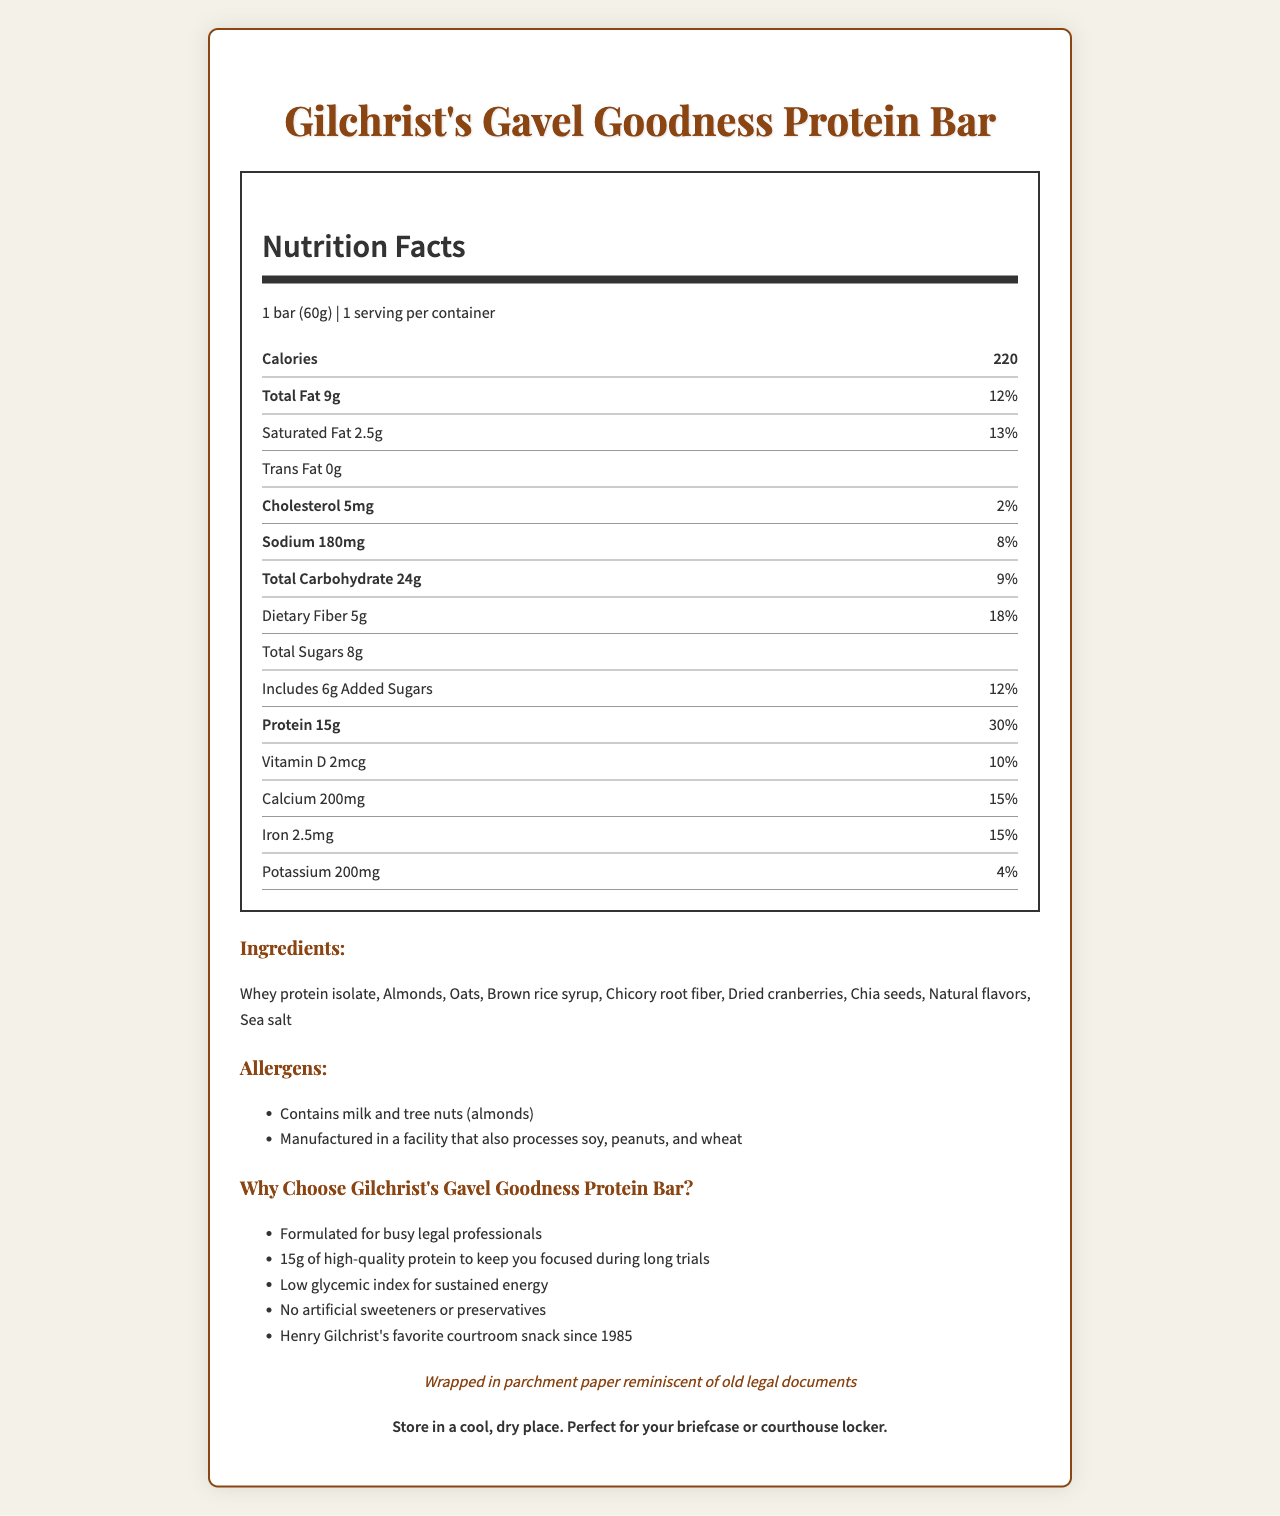what is the product name? The product name is clearly listed at the top of the document and in the title.
Answer: Gilchrist's Gavel Goodness Protein Bar what is the serving size for the protein bar? The serving size is provided immediately under the Nutrition Facts heading.
Answer: 1 bar (60g) how many calories does one serving contain? The calorie count is mentioned under the serving size in the Nutrition Facts section.
Answer: 220 what is the amount of total fat per serving? The total fat amount per serving is listed in the Nutrition Facts section following the calorie count.
Answer: 9g what are the allergens listed? The allergens information is provided in the Allergens section of the document.
Answer: Contains milk and tree nuts (almonds); Manufactured in a facility that also processes soy, peanuts, and wheat what ingredient comes first in the list? The ingredients are listed in the Ingredients section, with Whey protein isolate being the first item.
Answer: Whey protein isolate how much protein does the bar provide? The amount of protein is specified in the Nutrition Facts section.
Answer: 15g how is the bar wrapped? The nostalgic touch section describes the bar's wrapping.
Answer: Wrapped in parchment paper reminiscent of old legal documents which nutrient has the highest daily value percentage? The daily value percentage for protein is the highest at 30%, as shown in the Nutrition Facts section.
Answer: Protein with 30% what is the item stored best in? A. Refrigerator B. Freezer C. Cool, dry place D. Warm room The storage instructions specify that the bar should be stored in a cool, dry place.
Answer: C which ingredient contributes to natural sweetness? I. Whey protein isolate II. Brown rice syrup III. Chicory root fiber Brown rice syrup is known to contribute to sweetness.
Answer: II how many servings are in one container? The document states that there is 1 serving per container.
Answer: 1 serving does the bar include any artificial sweeteners or preservatives? (Yes/No) The marketing claims specifically state that the bar contains no artificial sweeteners or preservatives.
Answer: No summarize the main idea of the document The document provides detailed data on the protein bar's nutritional values, ingredients, allergens, and additional marketing claims, illustrating its health benefits and nostalgic packaging.
Answer: The document is a Nutrition Facts label for Gilchrist's Gavel Goodness Protein Bar. It provides comprehensive nutritional information, ingredient details, allergen warnings, and highlights its suitability for busy legal professionals, with a nostalgic reference to its packaging. how many marketing claims are listed? The marketing section lists five claims about the protein bar.
Answer: 5 claims what is the daily value percentage of saturated fat for this protein bar? The Nutrition Facts section lists the daily value percentage for saturated fat as 13%.
Answer: 13% who is mentioned as having this bar as a favorite courtroom snack since 1985? The marketing claims mention Henry Gilchrist's preference for this snack.
Answer: Henry Gilchrist what type of fiber is used in the bar? The Ingredients section lists Chicory root fiber as one of the ingredients.
Answer: Chicory root fiber what is the daily value percentage of calcium per serving? A. 10% B. 15% C. 20% D. 25% The Nutrition Facts section lists the daily value percentage for calcium as 15%.
Answer: B is the protein bar intended for legal professionals? One of the marketing claims states it is formulated for busy legal professionals.
Answer: Yes can the amount of potassium per serving be used to predict the sodium content accurately? The document provides the amounts for both potassium and sodium, but it doesn't establish a relationship between these two nutrients for predictive purposes.
Answer: Cannot be determined 